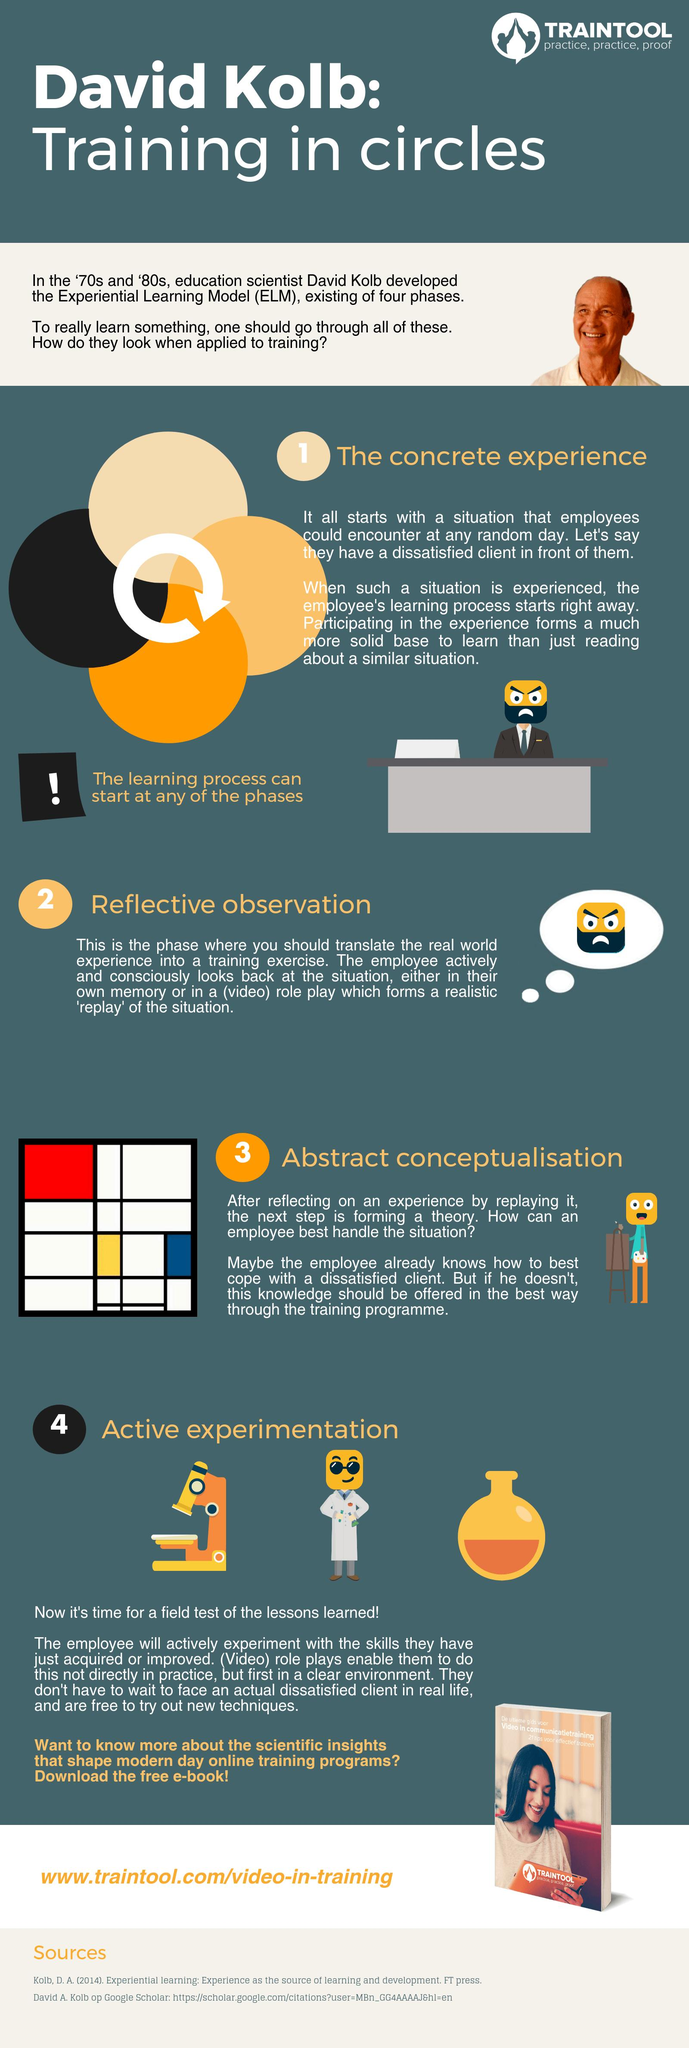Highlight a few significant elements in this photo. The number of sources listed is two. 